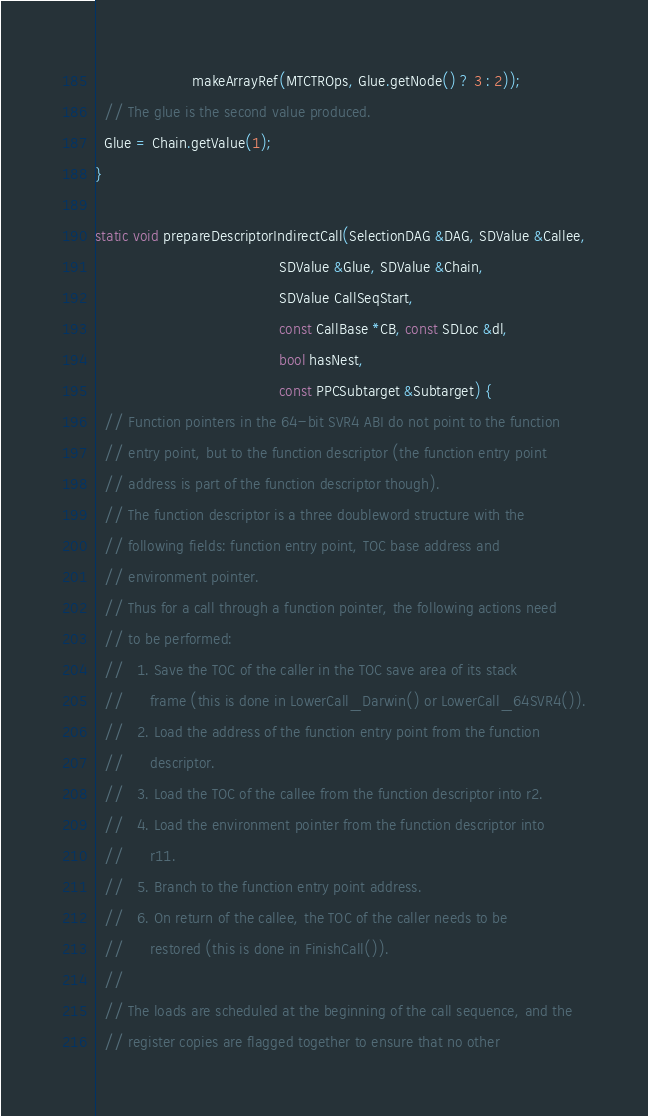Convert code to text. <code><loc_0><loc_0><loc_500><loc_500><_C++_>                      makeArrayRef(MTCTROps, Glue.getNode() ? 3 : 2));
  // The glue is the second value produced.
  Glue = Chain.getValue(1);
}

static void prepareDescriptorIndirectCall(SelectionDAG &DAG, SDValue &Callee,
                                          SDValue &Glue, SDValue &Chain,
                                          SDValue CallSeqStart,
                                          const CallBase *CB, const SDLoc &dl,
                                          bool hasNest,
                                          const PPCSubtarget &Subtarget) {
  // Function pointers in the 64-bit SVR4 ABI do not point to the function
  // entry point, but to the function descriptor (the function entry point
  // address is part of the function descriptor though).
  // The function descriptor is a three doubleword structure with the
  // following fields: function entry point, TOC base address and
  // environment pointer.
  // Thus for a call through a function pointer, the following actions need
  // to be performed:
  //   1. Save the TOC of the caller in the TOC save area of its stack
  //      frame (this is done in LowerCall_Darwin() or LowerCall_64SVR4()).
  //   2. Load the address of the function entry point from the function
  //      descriptor.
  //   3. Load the TOC of the callee from the function descriptor into r2.
  //   4. Load the environment pointer from the function descriptor into
  //      r11.
  //   5. Branch to the function entry point address.
  //   6. On return of the callee, the TOC of the caller needs to be
  //      restored (this is done in FinishCall()).
  //
  // The loads are scheduled at the beginning of the call sequence, and the
  // register copies are flagged together to ensure that no other</code> 